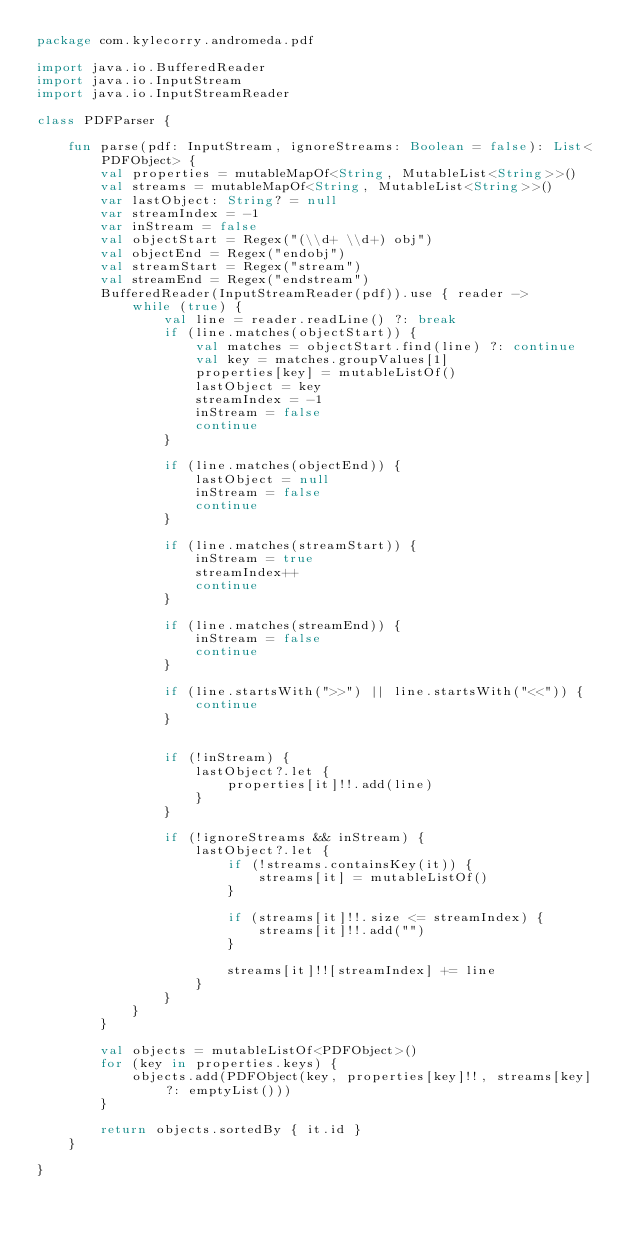Convert code to text. <code><loc_0><loc_0><loc_500><loc_500><_Kotlin_>package com.kylecorry.andromeda.pdf

import java.io.BufferedReader
import java.io.InputStream
import java.io.InputStreamReader

class PDFParser {

    fun parse(pdf: InputStream, ignoreStreams: Boolean = false): List<PDFObject> {
        val properties = mutableMapOf<String, MutableList<String>>()
        val streams = mutableMapOf<String, MutableList<String>>()
        var lastObject: String? = null
        var streamIndex = -1
        var inStream = false
        val objectStart = Regex("(\\d+ \\d+) obj")
        val objectEnd = Regex("endobj")
        val streamStart = Regex("stream")
        val streamEnd = Regex("endstream")
        BufferedReader(InputStreamReader(pdf)).use { reader ->
            while (true) {
                val line = reader.readLine() ?: break
                if (line.matches(objectStart)) {
                    val matches = objectStart.find(line) ?: continue
                    val key = matches.groupValues[1]
                    properties[key] = mutableListOf()
                    lastObject = key
                    streamIndex = -1
                    inStream = false
                    continue
                }

                if (line.matches(objectEnd)) {
                    lastObject = null
                    inStream = false
                    continue
                }

                if (line.matches(streamStart)) {
                    inStream = true
                    streamIndex++
                    continue
                }

                if (line.matches(streamEnd)) {
                    inStream = false
                    continue
                }

                if (line.startsWith(">>") || line.startsWith("<<")) {
                    continue
                }


                if (!inStream) {
                    lastObject?.let {
                        properties[it]!!.add(line)
                    }
                }

                if (!ignoreStreams && inStream) {
                    lastObject?.let {
                        if (!streams.containsKey(it)) {
                            streams[it] = mutableListOf()
                        }

                        if (streams[it]!!.size <= streamIndex) {
                            streams[it]!!.add("")
                        }

                        streams[it]!![streamIndex] += line
                    }
                }
            }
        }

        val objects = mutableListOf<PDFObject>()
        for (key in properties.keys) {
            objects.add(PDFObject(key, properties[key]!!, streams[key] ?: emptyList()))
        }

        return objects.sortedBy { it.id }
    }

}</code> 